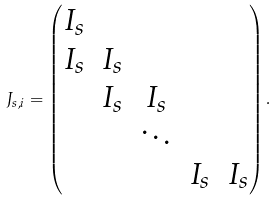<formula> <loc_0><loc_0><loc_500><loc_500>J _ { s , i } = \begin{pmatrix} I _ { s } \\ I _ { s } & I _ { s } \\ & I _ { s } & I _ { s } \\ & & \ddots \\ & & & I _ { s } & I _ { s } \end{pmatrix} .</formula> 